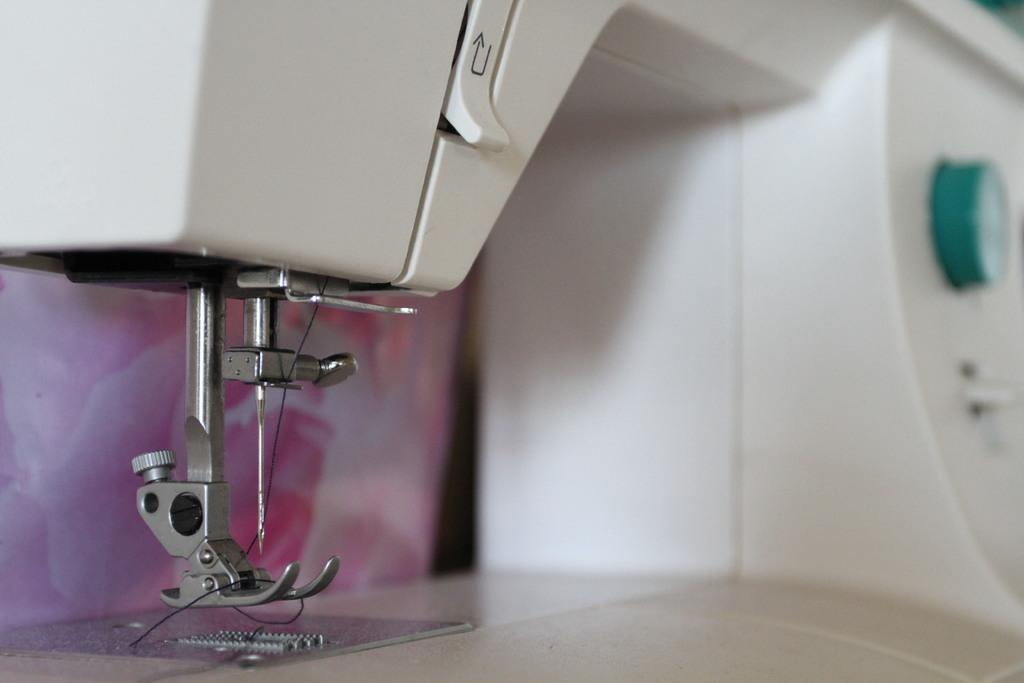What is the main object in the image? There is a sewing machine in the image. What is attached to the needle on the sewing machine? There is a thread in a needle in the image. What are the knobs on the sewing machine used for? The knobs on the sewing machine are used for adjusting settings and functions. What can be seen behind the sewing machine? There is a wall behind the sewing machine. What type of ring is the sewing machine wearing on its finger in the image? There is no ring present in the image, as sewing machines do not have fingers or wear rings. 